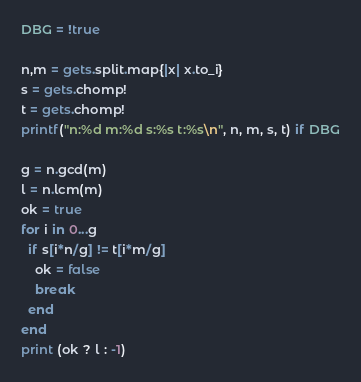Convert code to text. <code><loc_0><loc_0><loc_500><loc_500><_Ruby_>DBG = !true

n,m = gets.split.map{|x| x.to_i}
s = gets.chomp!
t = gets.chomp!
printf("n:%d m:%d s:%s t:%s\n", n, m, s, t) if DBG

g = n.gcd(m)
l = n.lcm(m)
ok = true
for i in 0...g
  if s[i*n/g] != t[i*m/g]
    ok = false
    break
  end
end
print (ok ? l : -1)
</code> 